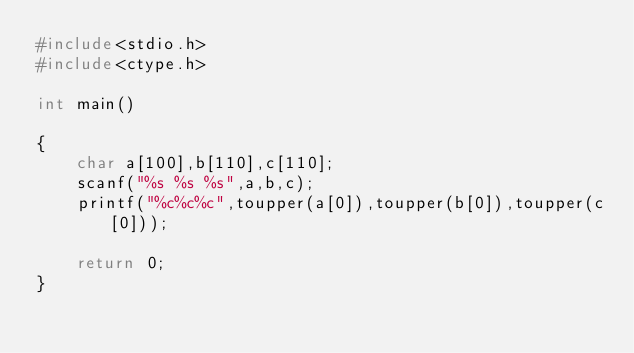Convert code to text. <code><loc_0><loc_0><loc_500><loc_500><_C_>#include<stdio.h>
#include<ctype.h>

int main()

{
    char a[100],b[110],c[110];
    scanf("%s %s %s",a,b,c);
    printf("%c%c%c",toupper(a[0]),toupper(b[0]),toupper(c[0]));

    return 0;
}
</code> 